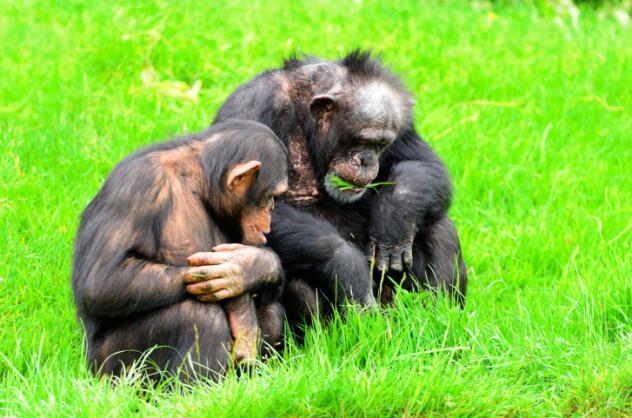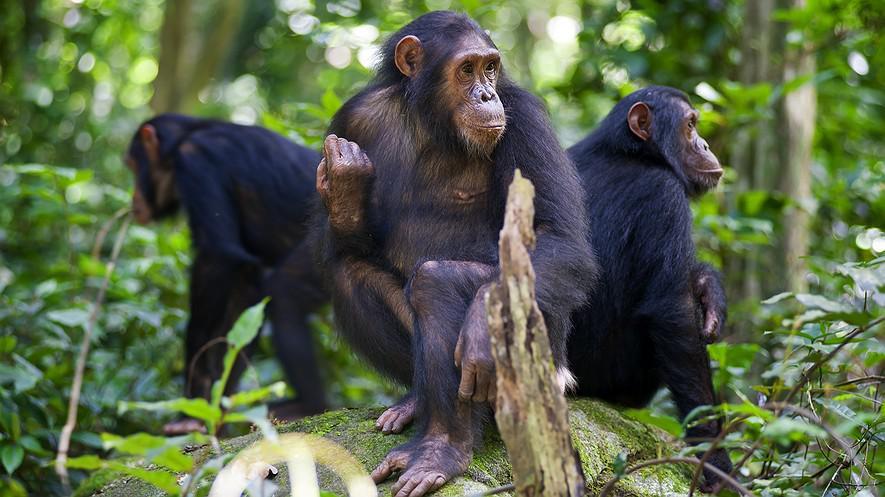The first image is the image on the left, the second image is the image on the right. Assess this claim about the two images: "There is atleast one extremely small baby monkey sitting next to a bigger adult sized monkey.". Correct or not? Answer yes or no. No. The first image is the image on the left, the second image is the image on the right. Assess this claim about the two images: "None of the chimpanzees appear to be young babies or toddlers; all are fully grown.". Correct or not? Answer yes or no. Yes. 